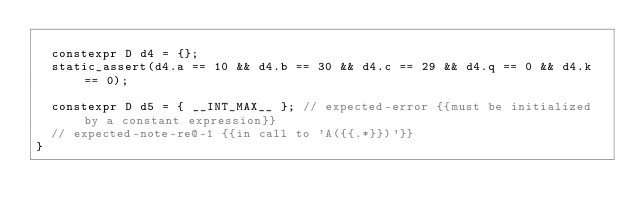<code> <loc_0><loc_0><loc_500><loc_500><_C++_>
  constexpr D d4 = {};
  static_assert(d4.a == 10 && d4.b == 30 && d4.c == 29 && d4.q == 0 && d4.k == 0);

  constexpr D d5 = { __INT_MAX__ }; // expected-error {{must be initialized by a constant expression}}
  // expected-note-re@-1 {{in call to 'A({{.*}})'}}
}
</code> 